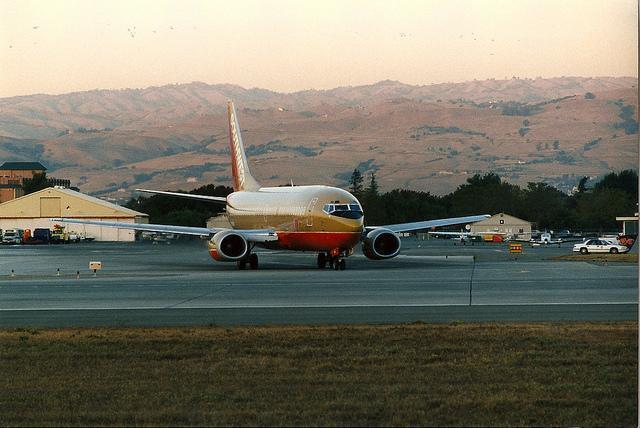What is the plane doing that requires it to be perpendicular to the runway?
Choose the correct response and explain in the format: 'Answer: answer
Rationale: rationale.'
Options: Taking off, boarding, taxiing, landing. Answer: taxiing.
Rationale: The airplane is currently taxiing. 